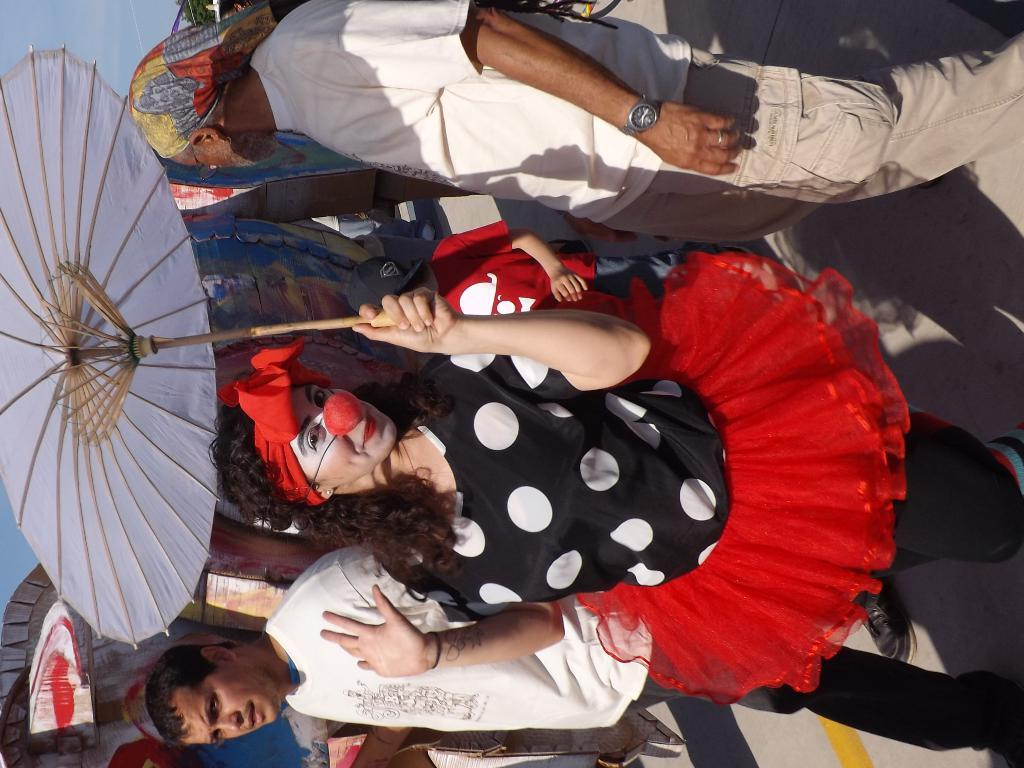How many people are in the image? There are people in the image, but the exact number is not specified. What object is being held by one of the people in the image? One woman is holding an umbrella in the image. What type of produce is being harvested by the people in the image? There is no mention of produce or harvesting in the image, so it cannot be determined from the facts provided. 